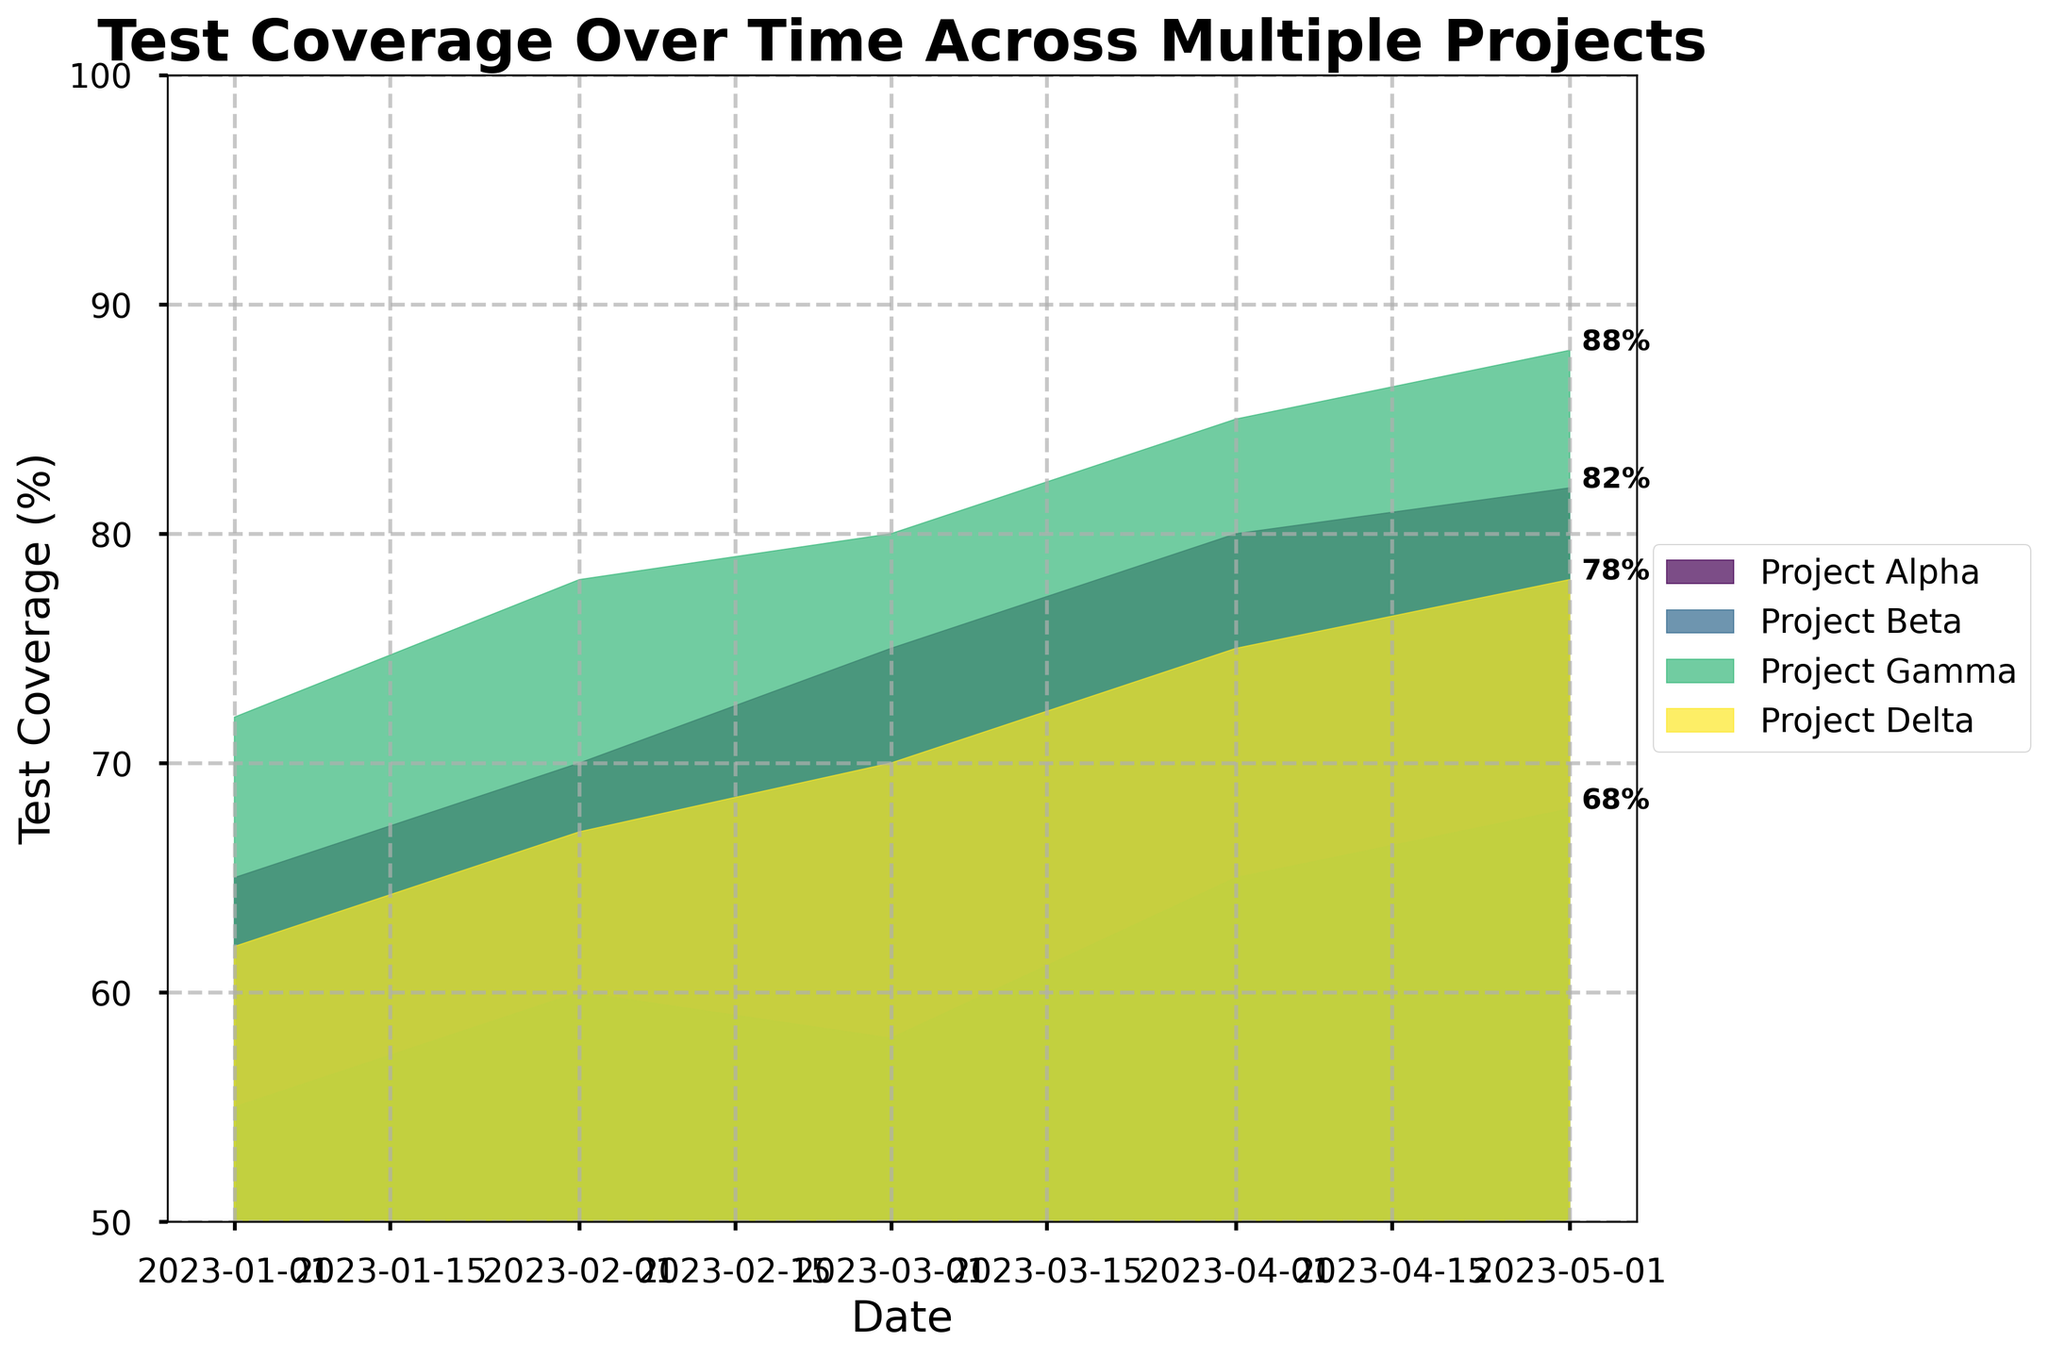Which project has the highest test coverage in May 2023? Look at the values in May 2023 for all projects and compare their heights. Project Gamma reaches the highest value, indicating the highest test coverage.
Answer: Project Gamma How did the test coverage change for Project Beta from March 2023 to April 2023? Locate the test coverage values for Project Beta in March 2023 and April 2023. Subtract the March value (58%) from the April value (65%). The difference indicates the change.
Answer: Increased by 7% What is the overall trend of test coverage for Project Alpha over time? Observe the data points for Project Alpha from January to May. The coverage values consistently increase, indicating an upward trend in test coverage.
Answer: Upward trend Which project had the lowest initial test coverage in January 2023? Check the coverage values for all projects in January 2023. Project Beta has the lowest initial coverage value (55%).
Answer: Project Beta How much higher was Project Gamma's test coverage in May 2023 compared to Project Delta? Find the coverage values in May 2023 for both Project Gamma (88%) and Project Delta (78%). Subtract Delta's value from Gamma's value.
Answer: 10% higher By how many percentage points did Project Alpha's test coverage increase from January 2023 to May 2023? Subtract the initial test coverage of Project Alpha in January (65%) from the final coverage in May (82%).
Answer: 17 percentage points Which two projects had the same test coverage in any given month, and what was the month? Compare the coverage values for each month across all projects. In February 2023, both Project Alpha and Project Delta had 67% coverage.
Answer: Project Alpha and Project Delta in February 2023 How does the variability in test coverage for Project Gamma compare to Project Beta over the time period? Examine the range of test coverage values for each project. Project Gamma's values vary from 72% to 88%, while Project Beta's values range from 55% to 68%, indicating greater variability in Project Gamma.
Answer: Greater variability in Project Gamma 